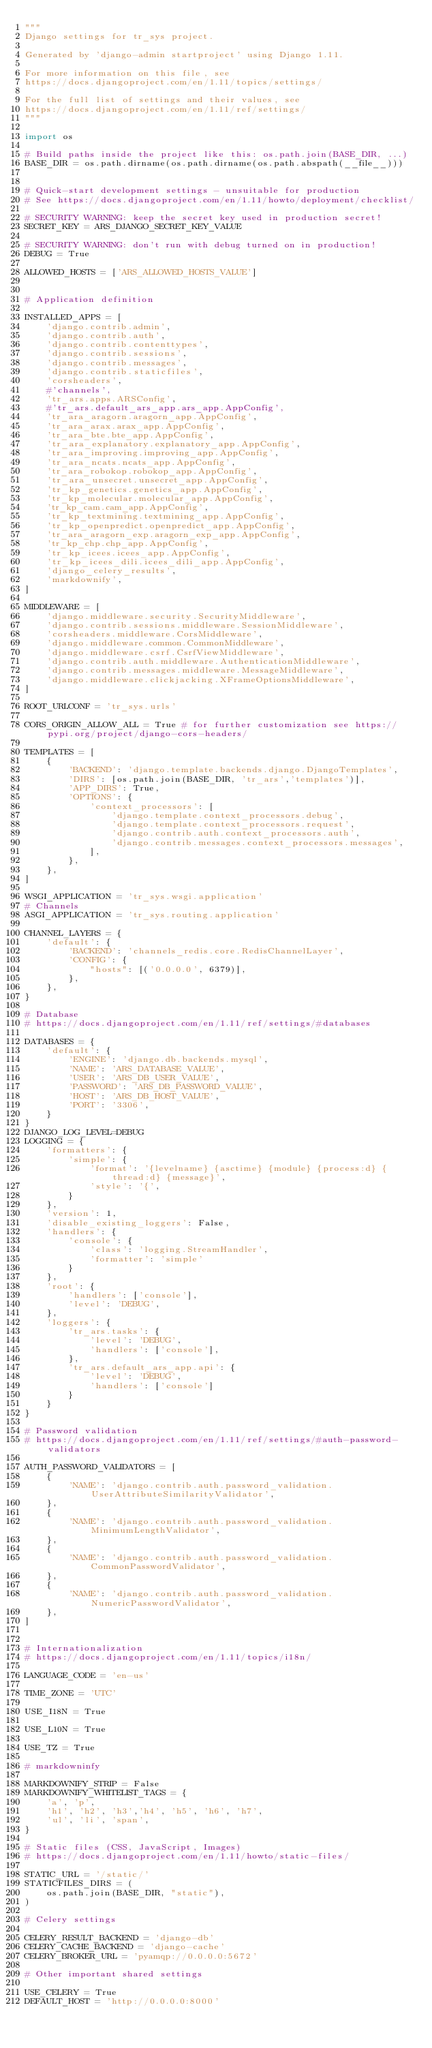Convert code to text. <code><loc_0><loc_0><loc_500><loc_500><_Python_>"""
Django settings for tr_sys project.

Generated by 'django-admin startproject' using Django 1.11.

For more information on this file, see
https://docs.djangoproject.com/en/1.11/topics/settings/

For the full list of settings and their values, see
https://docs.djangoproject.com/en/1.11/ref/settings/
"""

import os

# Build paths inside the project like this: os.path.join(BASE_DIR, ...)
BASE_DIR = os.path.dirname(os.path.dirname(os.path.abspath(__file__)))


# Quick-start development settings - unsuitable for production
# See https://docs.djangoproject.com/en/1.11/howto/deployment/checklist/

# SECURITY WARNING: keep the secret key used in production secret!
SECRET_KEY = ARS_DJANGO_SECRET_KEY_VALUE

# SECURITY WARNING: don't run with debug turned on in production!
DEBUG = True

ALLOWED_HOSTS = ['ARS_ALLOWED_HOSTS_VALUE']


# Application definition

INSTALLED_APPS = [
    'django.contrib.admin',
    'django.contrib.auth',
    'django.contrib.contenttypes',
    'django.contrib.sessions',
    'django.contrib.messages',
    'django.contrib.staticfiles',
    'corsheaders',
    #'channels',
    'tr_ars.apps.ARSConfig',
    #'tr_ars.default_ars_app.ars_app.AppConfig',
    'tr_ara_aragorn.aragorn_app.AppConfig',
    'tr_ara_arax.arax_app.AppConfig',
    'tr_ara_bte.bte_app.AppConfig',
    'tr_ara_explanatory.explanatory_app.AppConfig',
    'tr_ara_improving.improving_app.AppConfig',
    'tr_ara_ncats.ncats_app.AppConfig',
    'tr_ara_robokop.robokop_app.AppConfig',
    'tr_ara_unsecret.unsecret_app.AppConfig',
    'tr_kp_genetics.genetics_app.AppConfig',
    'tr_kp_molecular.molecular_app.AppConfig',
    'tr_kp_cam.cam_app.AppConfig',
    'tr_kp_textmining.textmining_app.AppConfig',
    'tr_kp_openpredict.openpredict_app.AppConfig',
    'tr_ara_aragorn_exp.aragorn_exp_app.AppConfig',
    'tr_kp_chp.chp_app.AppConfig',
    'tr_kp_icees.icees_app.AppConfig',
    'tr_kp_icees_dili.icees_dili_app.AppConfig',
    'django_celery_results',
    'markdownify',
]

MIDDLEWARE = [
    'django.middleware.security.SecurityMiddleware',
    'django.contrib.sessions.middleware.SessionMiddleware',
    'corsheaders.middleware.CorsMiddleware',
    'django.middleware.common.CommonMiddleware',
    'django.middleware.csrf.CsrfViewMiddleware',
    'django.contrib.auth.middleware.AuthenticationMiddleware',
    'django.contrib.messages.middleware.MessageMiddleware',
    'django.middleware.clickjacking.XFrameOptionsMiddleware',
]

ROOT_URLCONF = 'tr_sys.urls'

CORS_ORIGIN_ALLOW_ALL = True # for further customization see https://pypi.org/project/django-cors-headers/

TEMPLATES = [
    {
        'BACKEND': 'django.template.backends.django.DjangoTemplates',
        'DIRS': [os.path.join(BASE_DIR, 'tr_ars','templates')],
        'APP_DIRS': True,
        'OPTIONS': {
            'context_processors': [
                'django.template.context_processors.debug',
                'django.template.context_processors.request',
                'django.contrib.auth.context_processors.auth',
                'django.contrib.messages.context_processors.messages',
            ],
        },
    },
]

WSGI_APPLICATION = 'tr_sys.wsgi.application'
# Channels
ASGI_APPLICATION = 'tr_sys.routing.application'

CHANNEL_LAYERS = {
    'default': {
        'BACKEND': 'channels_redis.core.RedisChannelLayer',
        'CONFIG': {
            "hosts": [('0.0.0.0', 6379)],
        },
    },
}

# Database
# https://docs.djangoproject.com/en/1.11/ref/settings/#databases

DATABASES = {
    'default': {
        'ENGINE': 'django.db.backends.mysql',
        'NAME': 'ARS_DATABASE_VALUE',
        'USER': 'ARS_DB_USER_VALUE',
        'PASSWORD': 'ARS_DB_PASSWORD_VALUE',
        'HOST': 'ARS_DB_HOST_VALUE',
        'PORT': '3306',
    }
}
DJANGO_LOG_LEVEL=DEBUG
LOGGING = {
    'formatters': {
        'simple': {
            'format': '{levelname} {asctime} {module} {process:d} {thread:d} {message}',
            'style': '{',
        }
    },
    'version': 1,
    'disable_existing_loggers': False,
    'handlers': {
        'console': {
            'class': 'logging.StreamHandler',
            'formatter': 'simple'
        }
    },
    'root': {
        'handlers': ['console'],
        'level': 'DEBUG',
    },
    'loggers': {
        'tr_ars.tasks': {
            'level': 'DEBUG',
            'handlers': ['console'],
        },
        'tr_ars.default_ars_app.api': {
            'level': 'DEBUG',
            'handlers': ['console']
        }
    }
}

# Password validation
# https://docs.djangoproject.com/en/1.11/ref/settings/#auth-password-validators

AUTH_PASSWORD_VALIDATORS = [
    {
        'NAME': 'django.contrib.auth.password_validation.UserAttributeSimilarityValidator',
    },
    {
        'NAME': 'django.contrib.auth.password_validation.MinimumLengthValidator',
    },
    {
        'NAME': 'django.contrib.auth.password_validation.CommonPasswordValidator',
    },
    {
        'NAME': 'django.contrib.auth.password_validation.NumericPasswordValidator',
    },
]


# Internationalization
# https://docs.djangoproject.com/en/1.11/topics/i18n/

LANGUAGE_CODE = 'en-us'

TIME_ZONE = 'UTC'

USE_I18N = True

USE_L10N = True

USE_TZ = True

# markdowninfy

MARKDOWNIFY_STRIP = False
MARKDOWNIFY_WHITELIST_TAGS = {
    'a', 'p',
    'h1', 'h2', 'h3','h4', 'h5', 'h6', 'h7',
    'ul', 'li', 'span',
}

# Static files (CSS, JavaScript, Images)
# https://docs.djangoproject.com/en/1.11/howto/static-files/

STATIC_URL = '/static/'
STATICFILES_DIRS = (
    os.path.join(BASE_DIR, "static"),
)

# Celery settings

CELERY_RESULT_BACKEND = 'django-db'
CELERY_CACHE_BACKEND = 'django-cache'
CELERY_BROKER_URL = 'pyamqp://0.0.0.0:5672'

# Other important shared settings

USE_CELERY = True
DEFAULT_HOST = 'http://0.0.0.0:8000'
</code> 